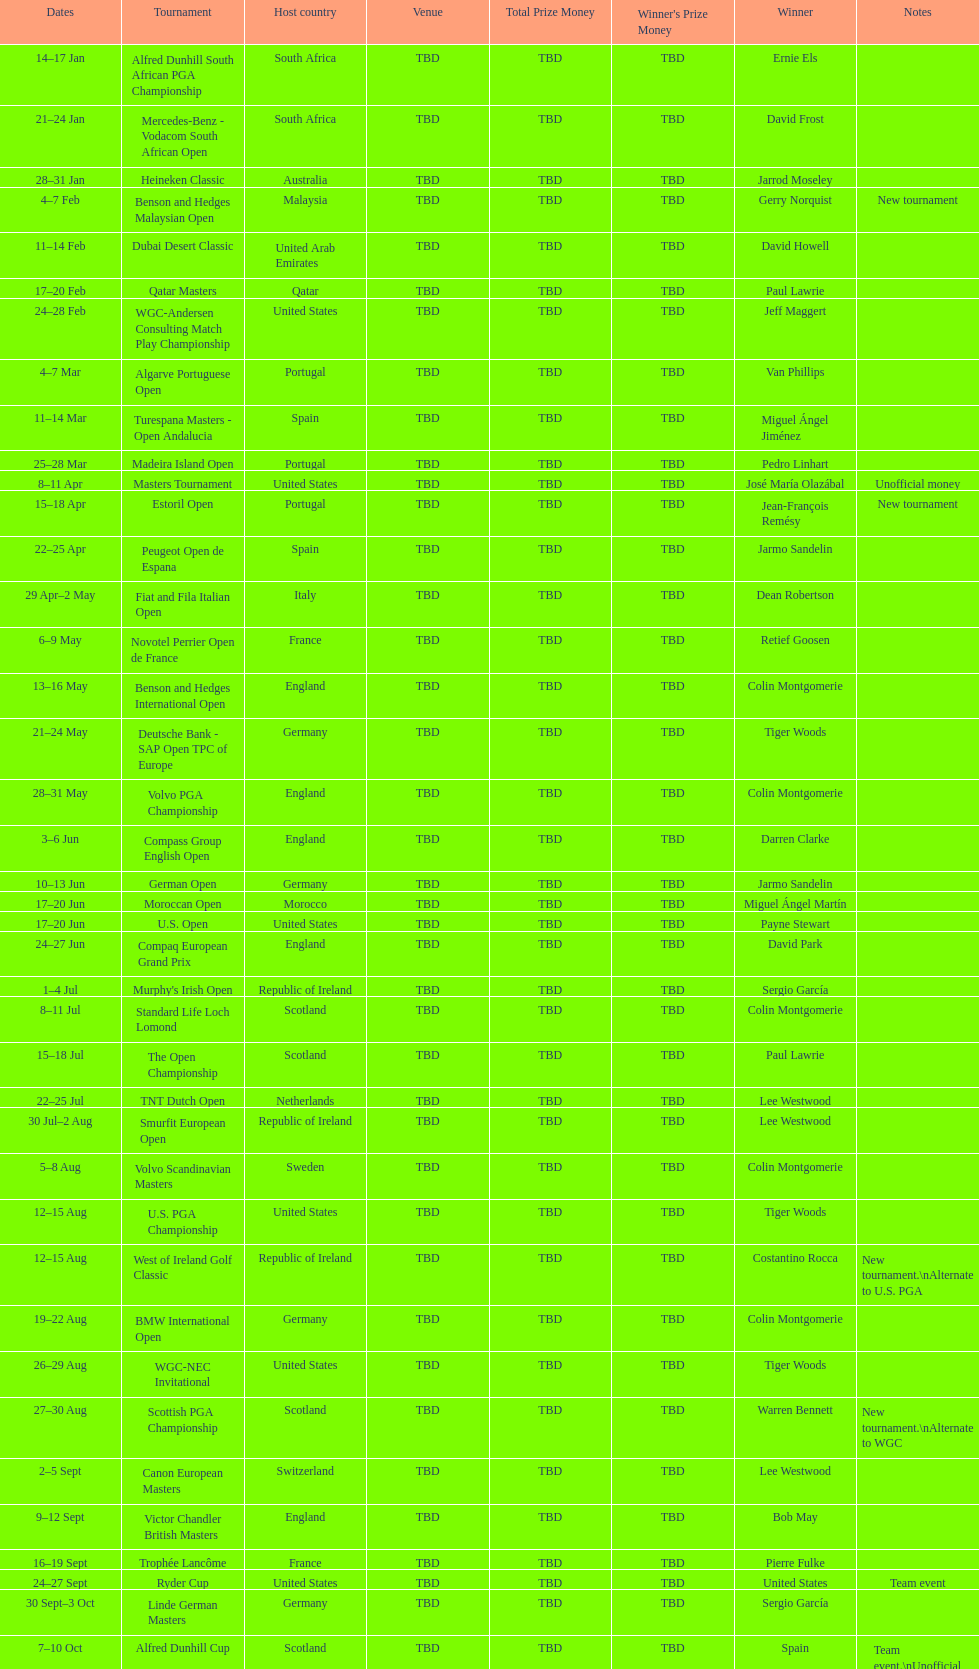Could you help me parse every detail presented in this table? {'header': ['Dates', 'Tournament', 'Host country', 'Venue', 'Total Prize Money', "Winner's Prize Money", 'Winner', 'Notes'], 'rows': [['14–17\xa0Jan', 'Alfred Dunhill South African PGA Championship', 'South Africa', 'TBD', 'TBD', 'TBD', 'Ernie Els', ''], ['21–24\xa0Jan', 'Mercedes-Benz - Vodacom South African Open', 'South Africa', 'TBD', 'TBD', 'TBD', 'David Frost', ''], ['28–31\xa0Jan', 'Heineken Classic', 'Australia', 'TBD', 'TBD', 'TBD', 'Jarrod Moseley', ''], ['4–7\xa0Feb', 'Benson and Hedges Malaysian Open', 'Malaysia', 'TBD', 'TBD', 'TBD', 'Gerry Norquist', 'New tournament'], ['11–14\xa0Feb', 'Dubai Desert Classic', 'United Arab Emirates', 'TBD', 'TBD', 'TBD', 'David Howell', ''], ['17–20\xa0Feb', 'Qatar Masters', 'Qatar', 'TBD', 'TBD', 'TBD', 'Paul Lawrie', ''], ['24–28\xa0Feb', 'WGC-Andersen Consulting Match Play Championship', 'United States', 'TBD', 'TBD', 'TBD', 'Jeff Maggert', ''], ['4–7\xa0Mar', 'Algarve Portuguese Open', 'Portugal', 'TBD', 'TBD', 'TBD', 'Van Phillips', ''], ['11–14\xa0Mar', 'Turespana Masters - Open Andalucia', 'Spain', 'TBD', 'TBD', 'TBD', 'Miguel Ángel Jiménez', ''], ['25–28\xa0Mar', 'Madeira Island Open', 'Portugal', 'TBD', 'TBD', 'TBD', 'Pedro Linhart', ''], ['8–11\xa0Apr', 'Masters Tournament', 'United States', 'TBD', 'TBD', 'TBD', 'José María Olazábal', 'Unofficial money'], ['15–18\xa0Apr', 'Estoril Open', 'Portugal', 'TBD', 'TBD', 'TBD', 'Jean-François Remésy', 'New tournament'], ['22–25\xa0Apr', 'Peugeot Open de Espana', 'Spain', 'TBD', 'TBD', 'TBD', 'Jarmo Sandelin', ''], ['29\xa0Apr–2\xa0May', 'Fiat and Fila Italian Open', 'Italy', 'TBD', 'TBD', 'TBD', 'Dean Robertson', ''], ['6–9\xa0May', 'Novotel Perrier Open de France', 'France', 'TBD', 'TBD', 'TBD', 'Retief Goosen', ''], ['13–16\xa0May', 'Benson and Hedges International Open', 'England', 'TBD', 'TBD', 'TBD', 'Colin Montgomerie', ''], ['21–24\xa0May', 'Deutsche Bank - SAP Open TPC of Europe', 'Germany', 'TBD', 'TBD', 'TBD', 'Tiger Woods', ''], ['28–31\xa0May', 'Volvo PGA Championship', 'England', 'TBD', 'TBD', 'TBD', 'Colin Montgomerie', ''], ['3–6\xa0Jun', 'Compass Group English Open', 'England', 'TBD', 'TBD', 'TBD', 'Darren Clarke', ''], ['10–13\xa0Jun', 'German Open', 'Germany', 'TBD', 'TBD', 'TBD', 'Jarmo Sandelin', ''], ['17–20\xa0Jun', 'Moroccan Open', 'Morocco', 'TBD', 'TBD', 'TBD', 'Miguel Ángel Martín', ''], ['17–20\xa0Jun', 'U.S. Open', 'United States', 'TBD', 'TBD', 'TBD', 'Payne Stewart', ''], ['24–27\xa0Jun', 'Compaq European Grand Prix', 'England', 'TBD', 'TBD', 'TBD', 'David Park', ''], ['1–4\xa0Jul', "Murphy's Irish Open", 'Republic of Ireland', 'TBD', 'TBD', 'TBD', 'Sergio García', ''], ['8–11\xa0Jul', 'Standard Life Loch Lomond', 'Scotland', 'TBD', 'TBD', 'TBD', 'Colin Montgomerie', ''], ['15–18\xa0Jul', 'The Open Championship', 'Scotland', 'TBD', 'TBD', 'TBD', 'Paul Lawrie', ''], ['22–25\xa0Jul', 'TNT Dutch Open', 'Netherlands', 'TBD', 'TBD', 'TBD', 'Lee Westwood', ''], ['30\xa0Jul–2\xa0Aug', 'Smurfit European Open', 'Republic of Ireland', 'TBD', 'TBD', 'TBD', 'Lee Westwood', ''], ['5–8\xa0Aug', 'Volvo Scandinavian Masters', 'Sweden', 'TBD', 'TBD', 'TBD', 'Colin Montgomerie', ''], ['12–15\xa0Aug', 'U.S. PGA Championship', 'United States', 'TBD', 'TBD', 'TBD', 'Tiger Woods', ''], ['12–15\xa0Aug', 'West of Ireland Golf Classic', 'Republic of Ireland', 'TBD', 'TBD', 'TBD', 'Costantino Rocca', 'New tournament.\\nAlternate to U.S. PGA'], ['19–22\xa0Aug', 'BMW International Open', 'Germany', 'TBD', 'TBD', 'TBD', 'Colin Montgomerie', ''], ['26–29\xa0Aug', 'WGC-NEC Invitational', 'United States', 'TBD', 'TBD', 'TBD', 'Tiger Woods', ''], ['27–30\xa0Aug', 'Scottish PGA Championship', 'Scotland', 'TBD', 'TBD', 'TBD', 'Warren Bennett', 'New tournament.\\nAlternate to WGC'], ['2–5\xa0Sept', 'Canon European Masters', 'Switzerland', 'TBD', 'TBD', 'TBD', 'Lee Westwood', ''], ['9–12\xa0Sept', 'Victor Chandler British Masters', 'England', 'TBD', 'TBD', 'TBD', 'Bob May', ''], ['16–19\xa0Sept', 'Trophée Lancôme', 'France', 'TBD', 'TBD', 'TBD', 'Pierre Fulke', ''], ['24–27\xa0Sept', 'Ryder Cup', 'United States', 'TBD', 'TBD', 'TBD', 'United States', 'Team event'], ['30\xa0Sept–3\xa0Oct', 'Linde German Masters', 'Germany', 'TBD', 'TBD', 'TBD', 'Sergio García', ''], ['7–10\xa0Oct', 'Alfred Dunhill Cup', 'Scotland', 'TBD', 'TBD', 'TBD', 'Spain', 'Team event.\\nUnofficial money'], ['14–17\xa0Oct', 'Cisco World Match Play Championship', 'England', 'TBD', 'TBD', 'TBD', 'Colin Montgomerie', 'Unofficial money'], ['14–17\xa0Oct', 'Sarazen World Open', 'Spain', 'TBD', 'TBD', 'TBD', 'Thomas Bjørn', 'New tournament'], ['21–24\xa0Oct', 'Belgacom Open', 'Belgium', 'TBD', 'TBD', 'TBD', 'Robert Karlsson', ''], ['28–31\xa0Oct', 'Volvo Masters', 'Spain', 'TBD', 'TBD', 'TBD', 'Miguel Ángel Jiménez', ''], ['4–7\xa0Nov', 'WGC-American Express Championship', 'Spain', 'TBD', 'TBD', 'TBD', 'Tiger Woods', ''], ['18–21\xa0Nov', 'World Cup of Golf', 'Malaysia', 'TBD', 'TBD', 'TBD', 'United States', 'Team event.\\nUnofficial money']]} What was the country listed the first time there was a new tournament? Malaysia. 